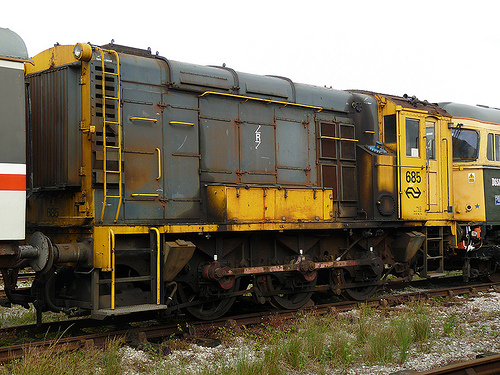Is the train yellow or is it gray? The train is gray. 